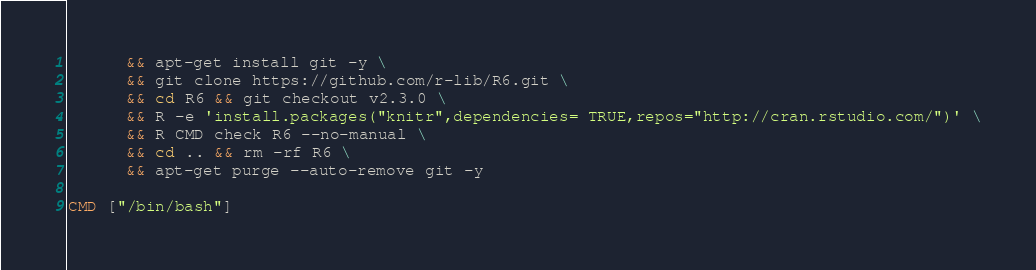<code> <loc_0><loc_0><loc_500><loc_500><_Dockerfile_>      && apt-get install git -y \
      && git clone https://github.com/r-lib/R6.git \
      && cd R6 && git checkout v2.3.0 \
      && R -e 'install.packages("knitr",dependencies= TRUE,repos="http://cran.rstudio.com/")' \
      && R CMD check R6 --no-manual \
      && cd .. && rm -rf R6 \
      && apt-get purge --auto-remove git -y

CMD ["/bin/bash"]
</code> 